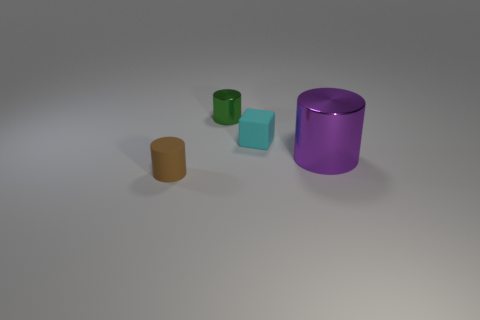Is the shape of the cyan rubber object the same as the big metal thing?
Provide a succinct answer. No. How many metal things are either purple spheres or green things?
Make the answer very short. 1. What number of gray metal cubes are there?
Provide a succinct answer. 0. The matte cylinder that is the same size as the cyan rubber block is what color?
Ensure brevity in your answer.  Brown. Does the green object have the same size as the purple metallic thing?
Your answer should be very brief. No. There is a purple shiny thing; is its size the same as the matte thing on the left side of the small green cylinder?
Your response must be concise. No. There is a cylinder that is left of the large shiny object and on the right side of the small rubber cylinder; what color is it?
Ensure brevity in your answer.  Green. Are there more tiny cylinders in front of the green object than metallic cylinders that are right of the purple cylinder?
Ensure brevity in your answer.  Yes. What is the size of the brown cylinder that is made of the same material as the block?
Your response must be concise. Small. How many cylinders are to the right of the small matte thing to the right of the matte cylinder?
Your answer should be very brief. 1. 